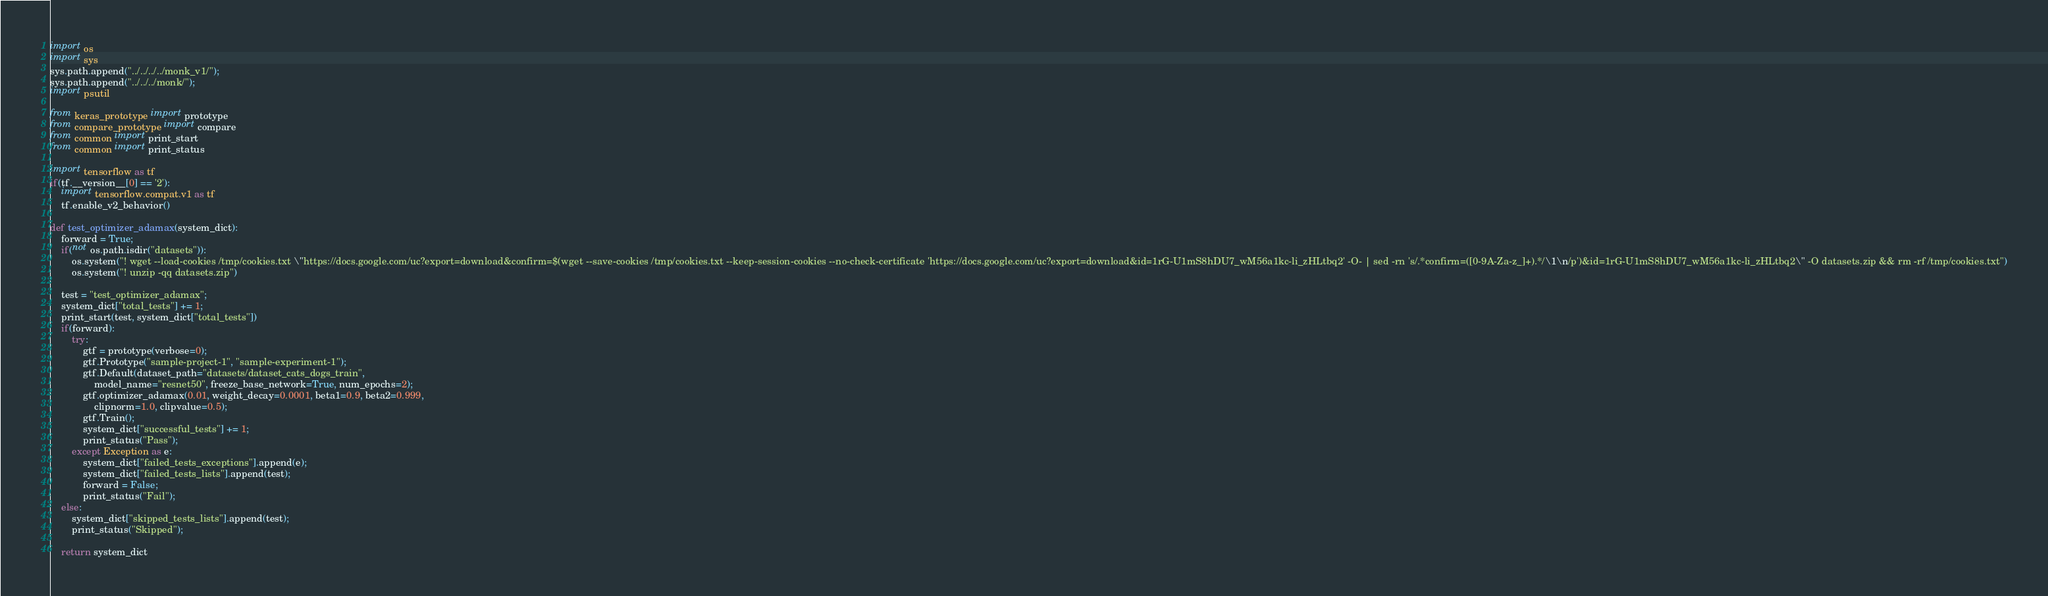<code> <loc_0><loc_0><loc_500><loc_500><_Python_>import os
import sys
sys.path.append("../../../../monk_v1/");
sys.path.append("../../../monk/");
import psutil

from keras_prototype import prototype
from compare_prototype import compare
from common import print_start
from common import print_status

import tensorflow as tf
if(tf.__version__[0] == '2'):
    import tensorflow.compat.v1 as tf
    tf.enable_v2_behavior()

def test_optimizer_adamax(system_dict):
    forward = True;
    if(not os.path.isdir("datasets")):
        os.system("! wget --load-cookies /tmp/cookies.txt \"https://docs.google.com/uc?export=download&confirm=$(wget --save-cookies /tmp/cookies.txt --keep-session-cookies --no-check-certificate 'https://docs.google.com/uc?export=download&id=1rG-U1mS8hDU7_wM56a1kc-li_zHLtbq2' -O- | sed -rn 's/.*confirm=([0-9A-Za-z_]+).*/\1\n/p')&id=1rG-U1mS8hDU7_wM56a1kc-li_zHLtbq2\" -O datasets.zip && rm -rf /tmp/cookies.txt")
        os.system("! unzip -qq datasets.zip")

    test = "test_optimizer_adamax";
    system_dict["total_tests"] += 1;
    print_start(test, system_dict["total_tests"])
    if(forward):
        try:
            gtf = prototype(verbose=0);
            gtf.Prototype("sample-project-1", "sample-experiment-1");
            gtf.Default(dataset_path="datasets/dataset_cats_dogs_train", 
                model_name="resnet50", freeze_base_network=True, num_epochs=2);
            gtf.optimizer_adamax(0.01, weight_decay=0.0001, beta1=0.9, beta2=0.999, 
            	clipnorm=1.0, clipvalue=0.5);
            gtf.Train();
            system_dict["successful_tests"] += 1;
            print_status("Pass");
        except Exception as e:
            system_dict["failed_tests_exceptions"].append(e);
            system_dict["failed_tests_lists"].append(test);
            forward = False;
            print_status("Fail");
    else:
        system_dict["skipped_tests_lists"].append(test);
        print_status("Skipped");

    return system_dict
</code> 